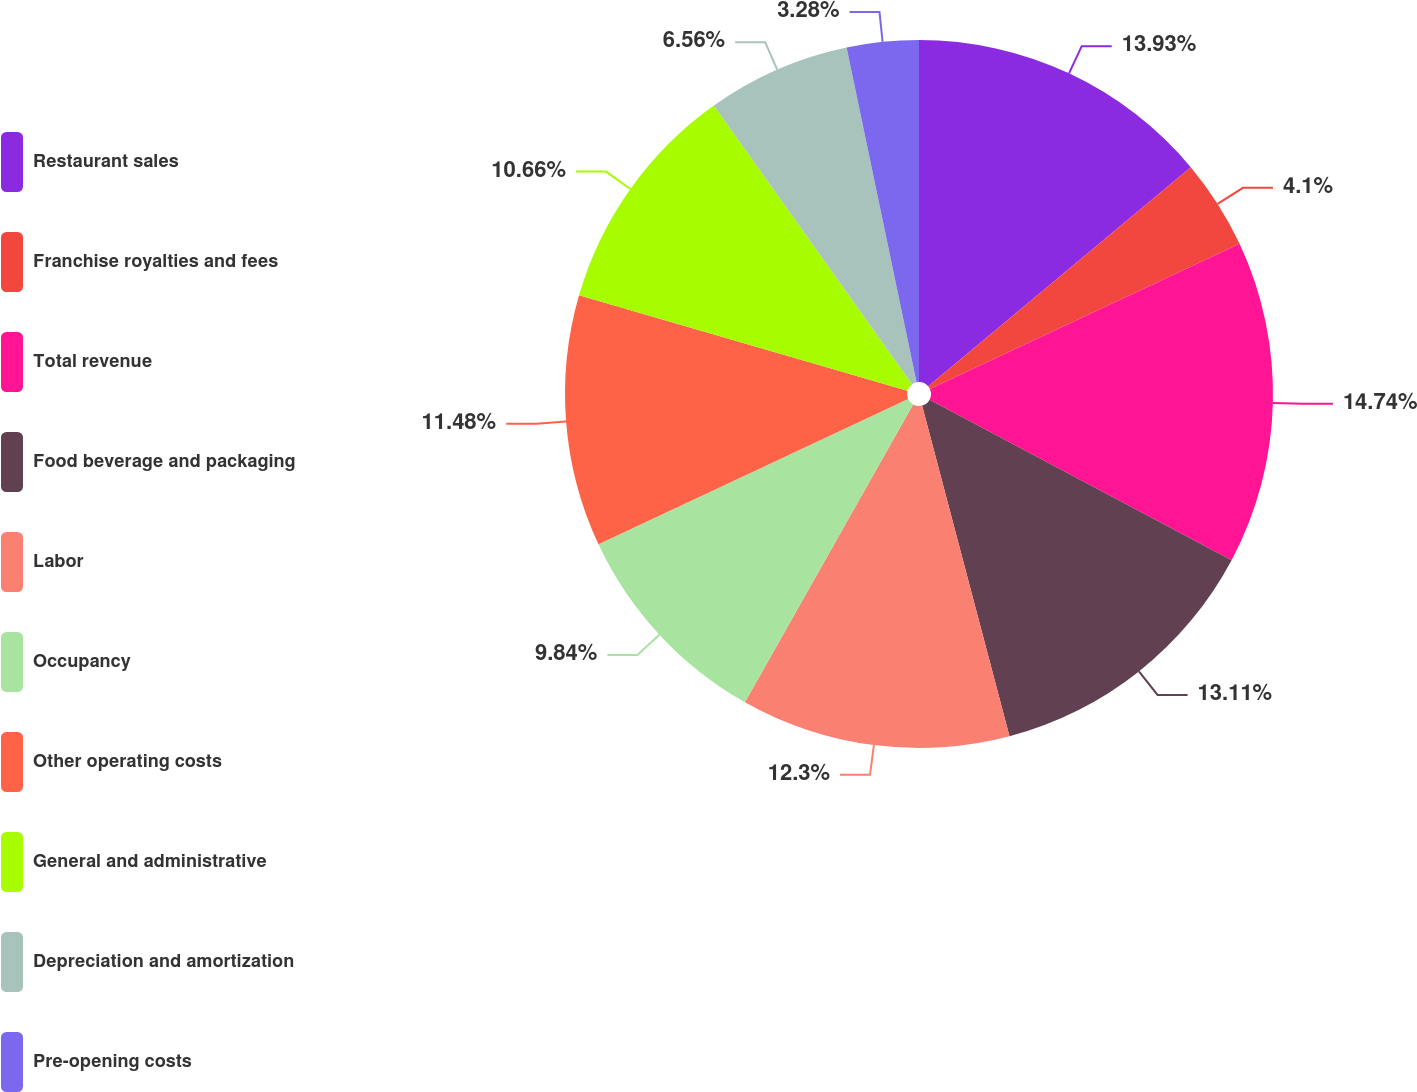<chart> <loc_0><loc_0><loc_500><loc_500><pie_chart><fcel>Restaurant sales<fcel>Franchise royalties and fees<fcel>Total revenue<fcel>Food beverage and packaging<fcel>Labor<fcel>Occupancy<fcel>Other operating costs<fcel>General and administrative<fcel>Depreciation and amortization<fcel>Pre-opening costs<nl><fcel>13.93%<fcel>4.1%<fcel>14.75%<fcel>13.11%<fcel>12.3%<fcel>9.84%<fcel>11.48%<fcel>10.66%<fcel>6.56%<fcel>3.28%<nl></chart> 